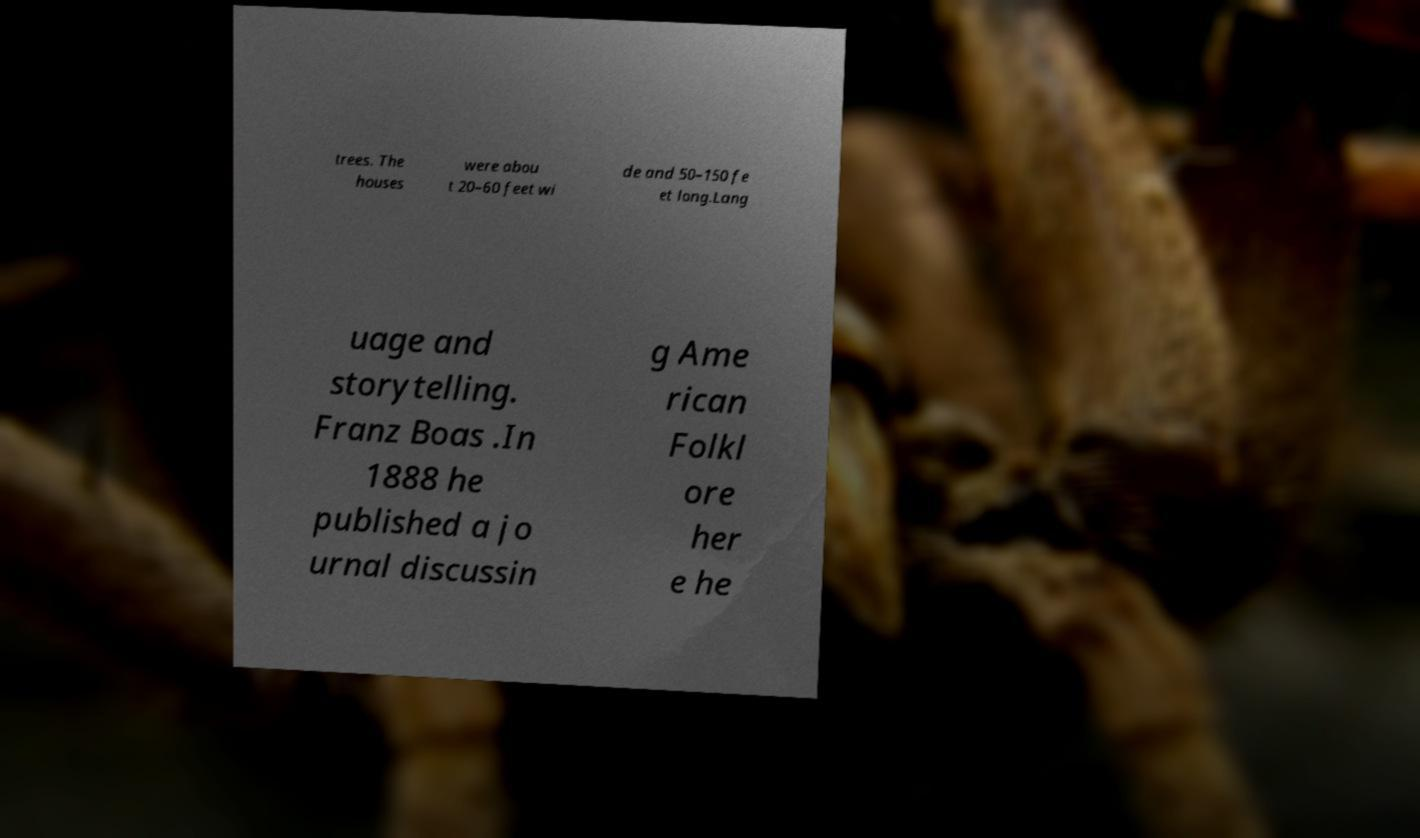What messages or text are displayed in this image? I need them in a readable, typed format. trees. The houses were abou t 20–60 feet wi de and 50–150 fe et long.Lang uage and storytelling. Franz Boas .In 1888 he published a jo urnal discussin g Ame rican Folkl ore her e he 